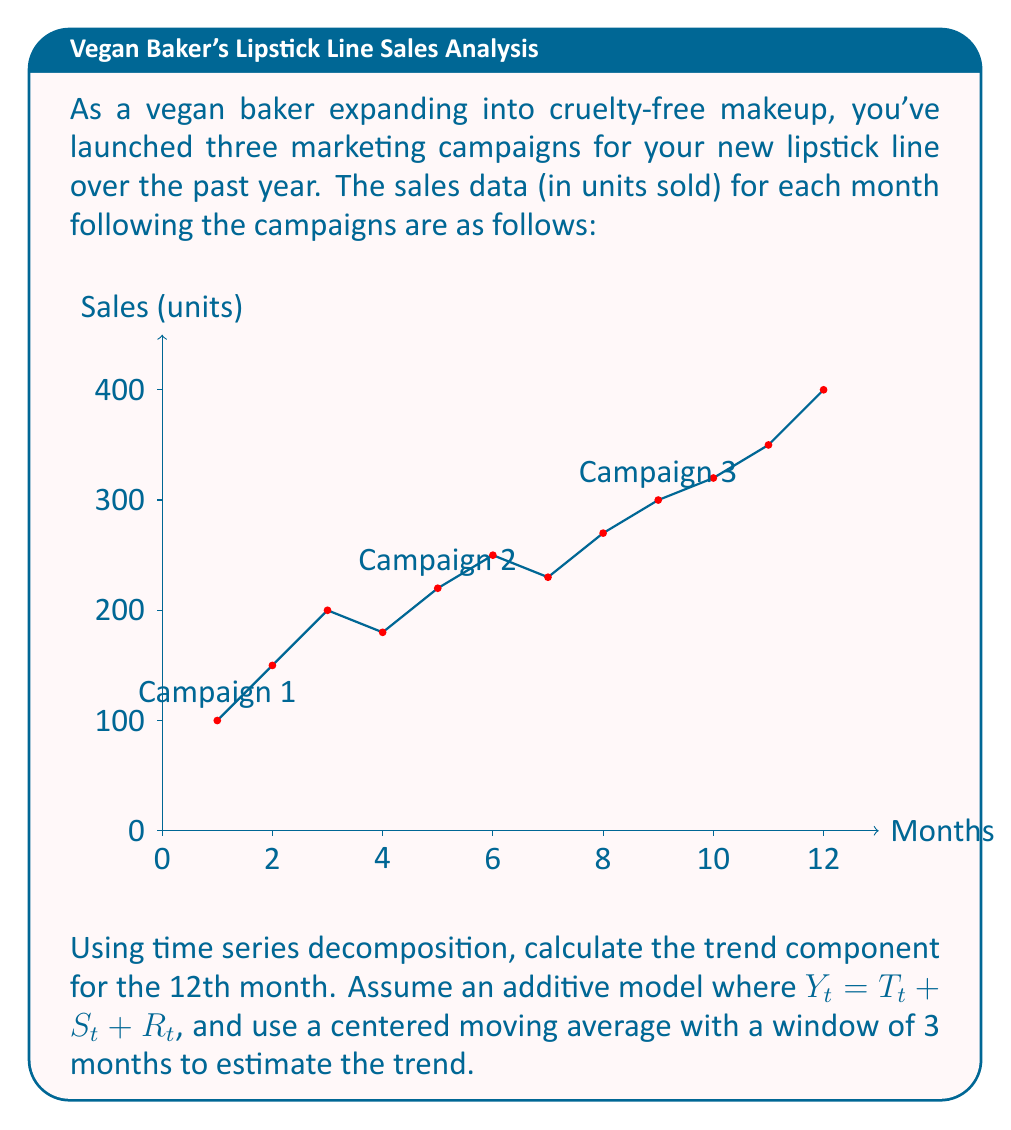Can you answer this question? To solve this problem, we'll follow these steps:

1) First, calculate the centered moving average (CMA) with a 3-month window:

   For month 2: $CMA_2 = \frac{100 + 150 + 200}{3} = 150$
   For month 3 to 11, we calculate similarly.
   For month 12, we don't have enough data.

2) The CMA values for months 2 to 11 are:
   150, 176.67, 200, 216.67, 233.33, 250, 266.67, 290, 323.33, 356.67

3) Now, we need to estimate the trend for month 12. We can do this by extrapolating from the last two available trend values:

   $T_{12} = T_{11} + (T_{11} - T_{10})$
   $T_{12} = 356.67 + (356.67 - 323.33) = 390$

4) Therefore, the estimated trend component for the 12th month is 390 units.

Note: This method assumes a linear trend continuation, which may not always be accurate in real-world scenarios. More sophisticated methods might be used for more precise forecasting.
Answer: 390 units 